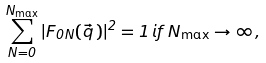<formula> <loc_0><loc_0><loc_500><loc_500>\sum _ { N = 0 } ^ { N _ { \max } } | F _ { 0 N } ( \vec { q } \, ) | ^ { 2 } = 1 \, i f \, N _ { \max } \rightarrow \infty \, ,</formula> 